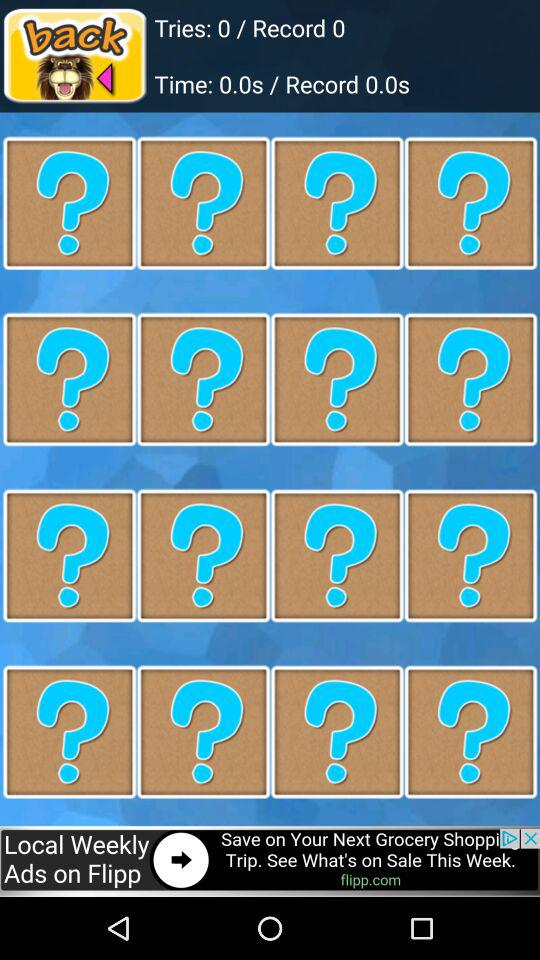What is the time? The time is 0 seconds. 